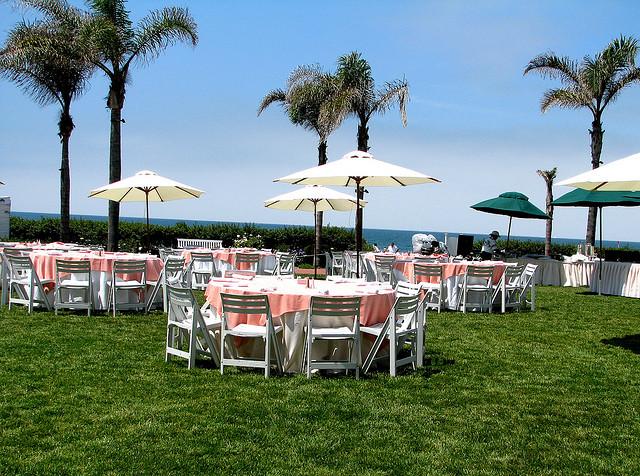What is this a photo of?
Be succinct. Party. Is there a view of the ocean?
Short answer required. Yes. Can the sun be seen in this photograph?
Give a very brief answer. No. 